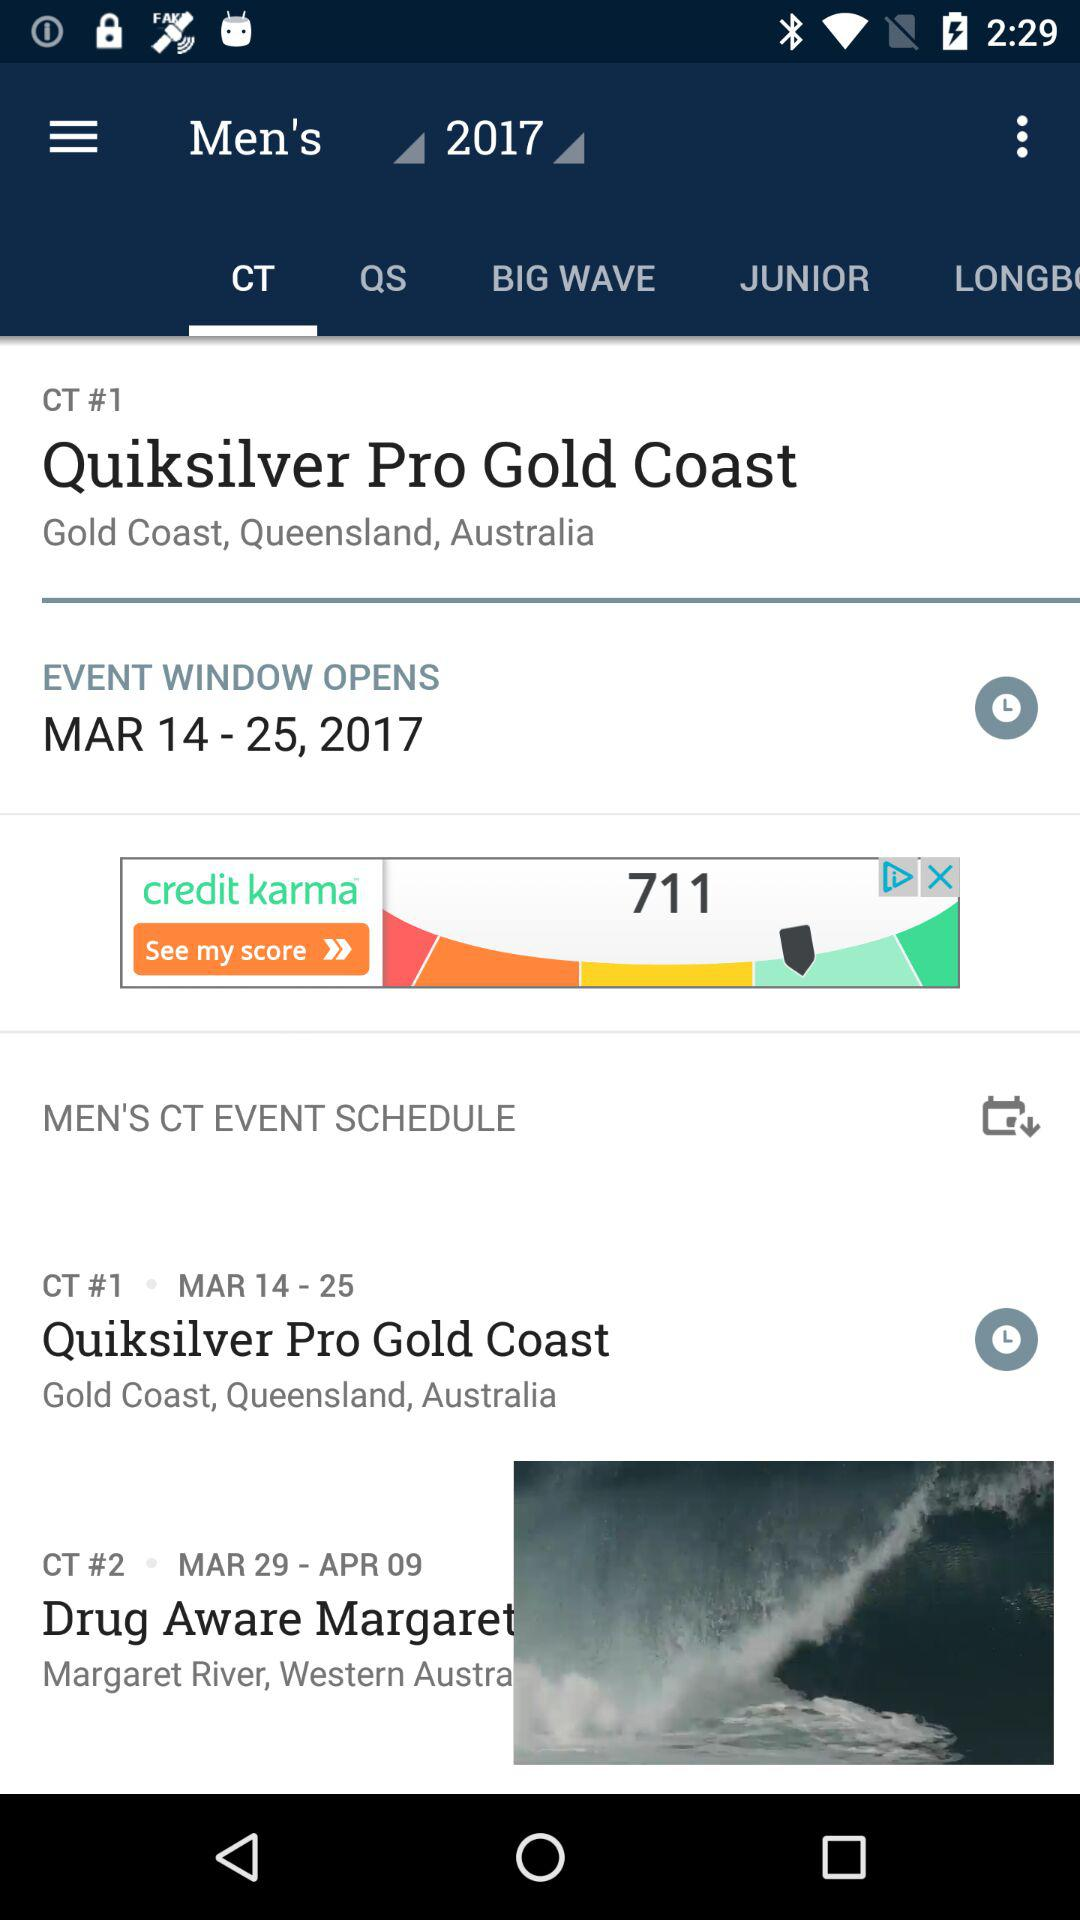What is the date range for "EVENT WINDOW OPENS"? The date range is from March 14, 2017 to March 25, 2017. 